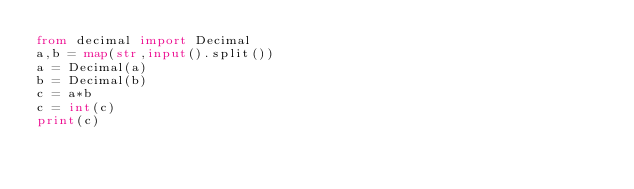<code> <loc_0><loc_0><loc_500><loc_500><_Python_>from decimal import Decimal
a,b = map(str,input().split())
a = Decimal(a)
b = Decimal(b)
c = a*b
c = int(c)
print(c)

</code> 